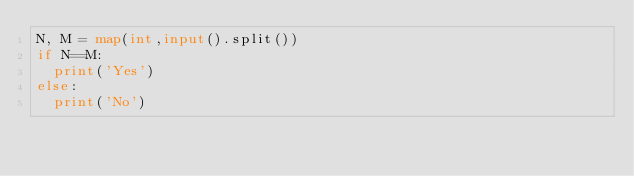Convert code to text. <code><loc_0><loc_0><loc_500><loc_500><_Python_>N, M = map(int,input().split())
if N==M:
  print('Yes')
else:
  print('No')</code> 